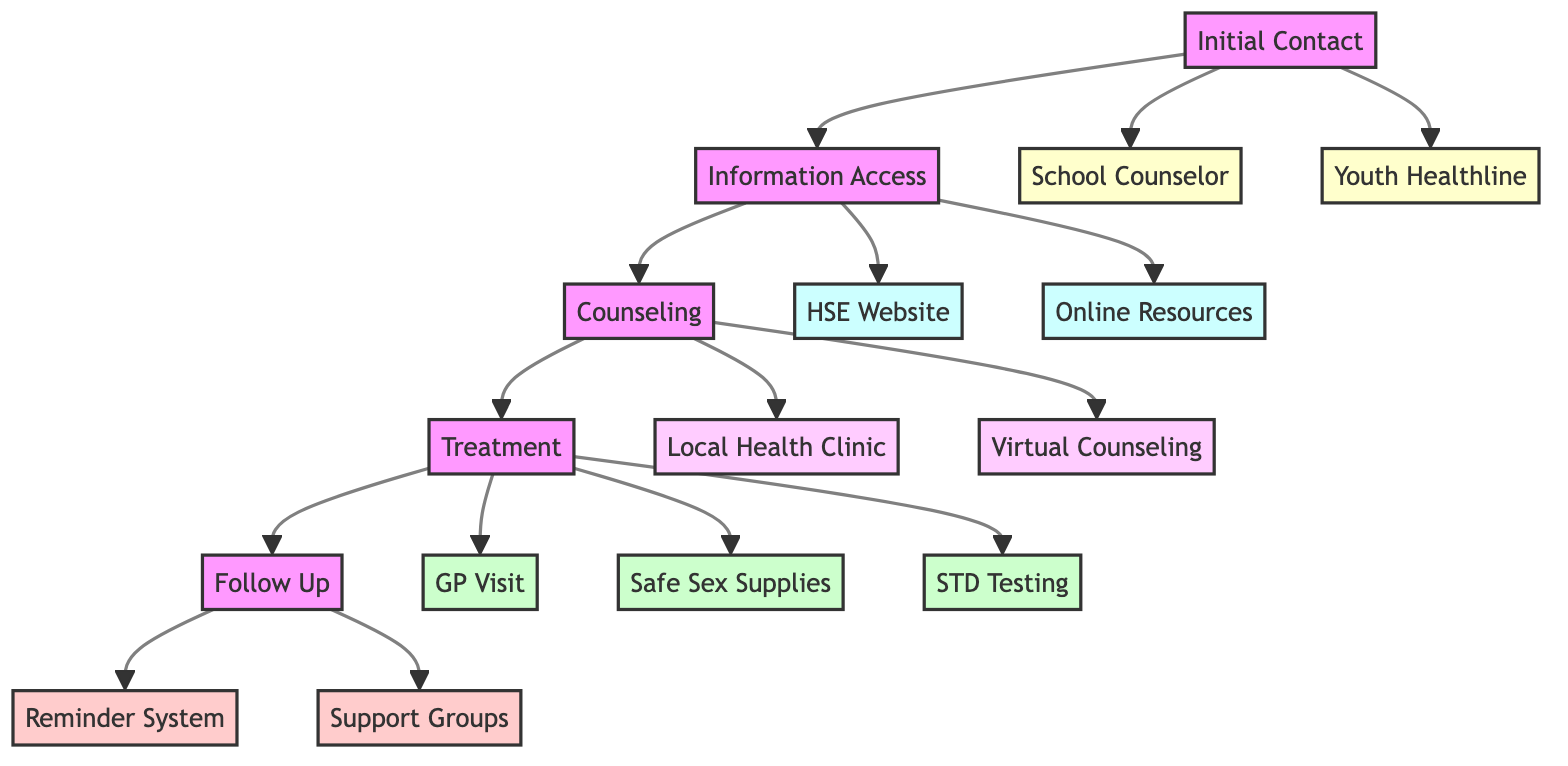What are the initial contact options for youth seeking sexual health services? The diagram identifies two options for initial contact: the School Counselor and the Youth Healthline. These provide different methods to access guidance related to sexual health.
Answer: School Counselor, Youth Healthline What’s the primary resource for comprehensive sexual health information? The HSE website is the specific resource outlined in the diagram that offers comprehensive sexual health information, signifying its importance in the information access phase.
Answer: HSE Website How many counseling options are available in the diagram? The diagram presents two distinct counseling options: Local Health Clinic and Virtual Counseling. Adding these together, we determine there are a total of two counseling avenues provided.
Answer: 2 What is the description of STD Testing in the treatment phase? The diagram describes STD Testing as offering confidential testing for sexually transmitted diseases. This highlights its focus on privacy and the health of youth.
Answer: Confidential testing for sexually transmitted diseases Which step follows the Treatment phase in the clinical pathway? The clinical pathway progresses from Treatment to Follow Up, indicating that support and check-ins are essential after receiving treatment for sexual health.
Answer: Follow Up In what locations are safe sex supplies available? The diagram indicates that safe sex supplies can be acquired at pharmacies, clinics, and via some school programs, providing multiple access points for youth.
Answer: Pharmacies, clinics, school programs What is the purpose of the Reminder System in the Follow Up phase? The Reminder System is designed to help set reminders for follow-up appointments and ongoing treatment, emphasizing organization and continued care for youth.
Answer: Set reminders for follow-up appointments What are the two types of online resources mentioned for information access? The diagram lists trusted online sources including SpunOut.ie and TeenHealth.com as two online resources that youth can utilize for research and self-education on sexual health topics.
Answer: SpunOut.ie, TeenHealth.com 